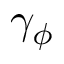Convert formula to latex. <formula><loc_0><loc_0><loc_500><loc_500>\gamma _ { \phi }</formula> 